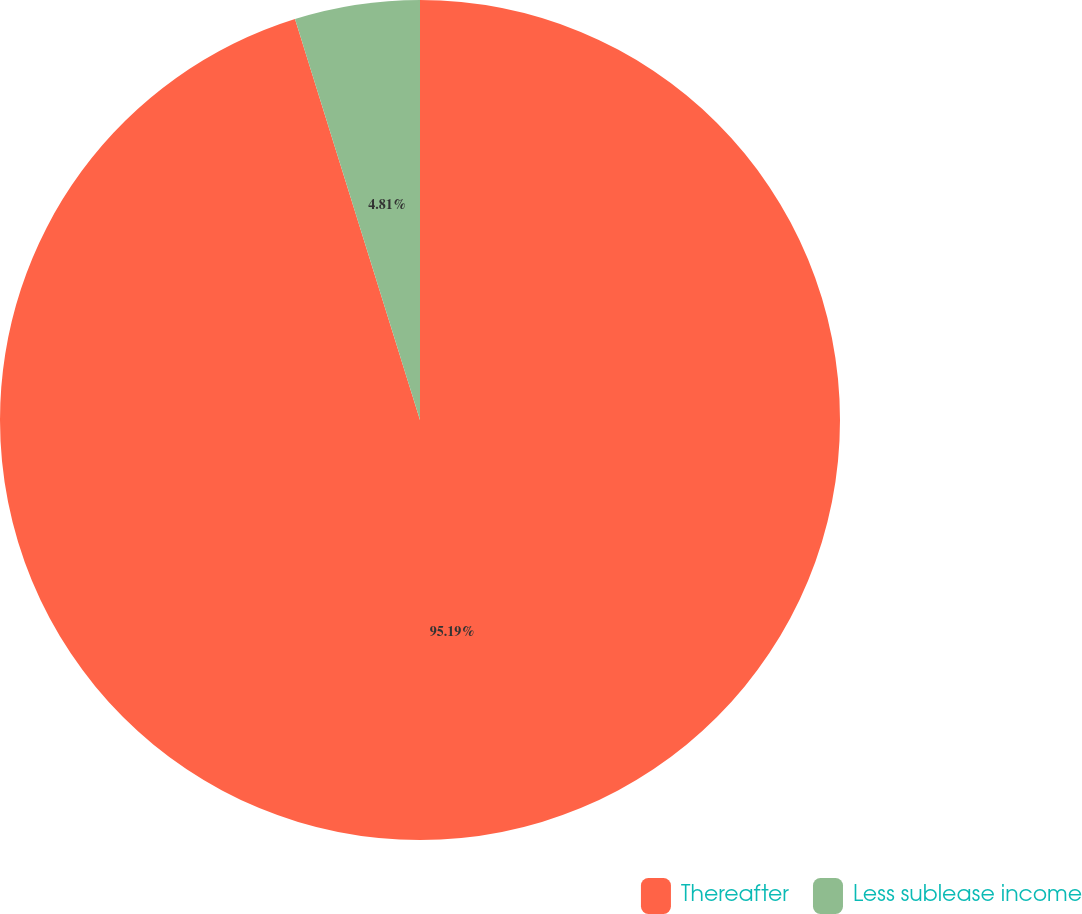<chart> <loc_0><loc_0><loc_500><loc_500><pie_chart><fcel>Thereafter<fcel>Less sublease income<nl><fcel>95.19%<fcel>4.81%<nl></chart> 